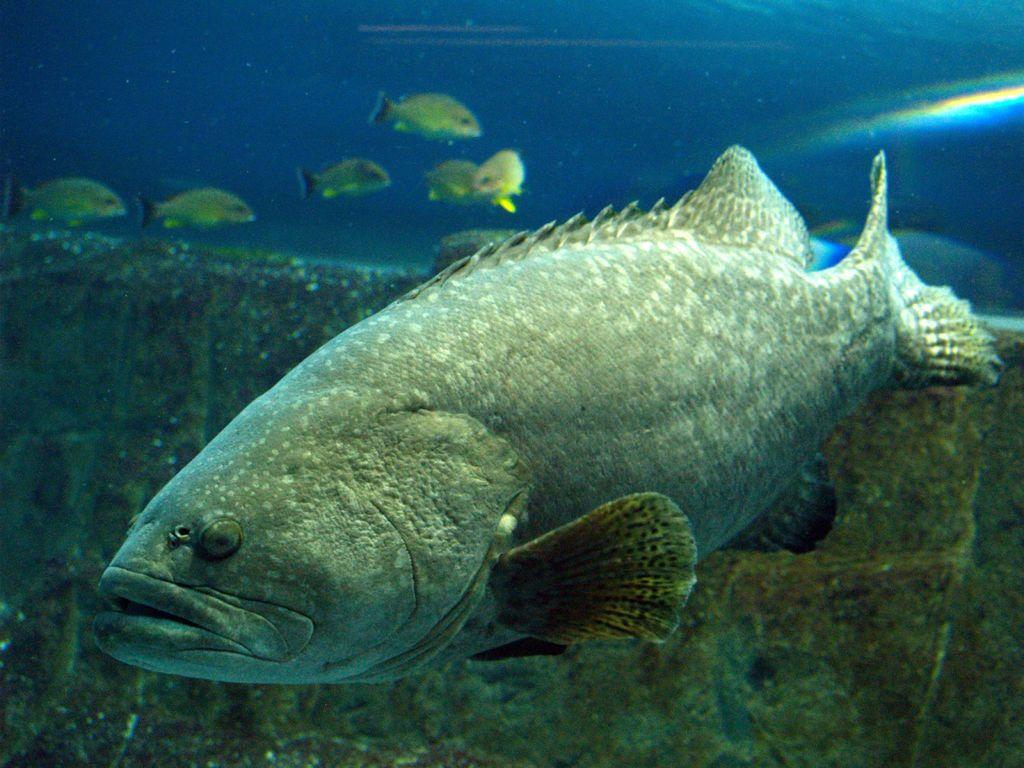What type of animals can be seen in the image? There are fishes in the image. What other elements are present in the image besides the fishes? There is greenery in the image. What type of book is being held by the finger in the image? There is no book or finger present in the image; it features fishes and greenery. 